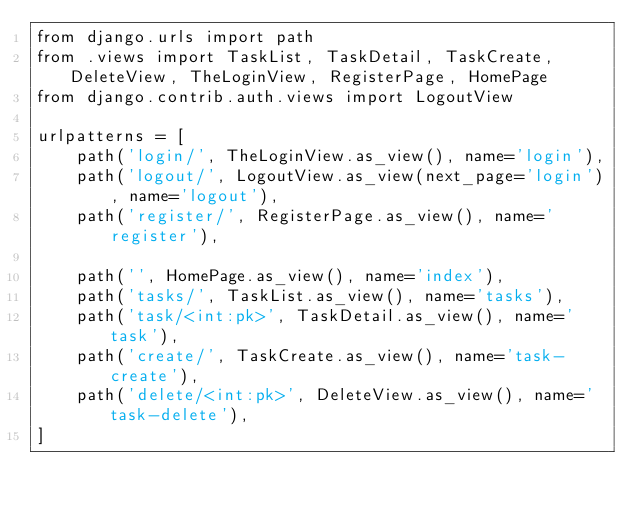<code> <loc_0><loc_0><loc_500><loc_500><_Python_>from django.urls import path
from .views import TaskList, TaskDetail, TaskCreate, DeleteView, TheLoginView, RegisterPage, HomePage
from django.contrib.auth.views import LogoutView

urlpatterns = [
    path('login/', TheLoginView.as_view(), name='login'),
    path('logout/', LogoutView.as_view(next_page='login'), name='logout'),
    path('register/', RegisterPage.as_view(), name='register'),

    path('', HomePage.as_view(), name='index'),
    path('tasks/', TaskList.as_view(), name='tasks'),
    path('task/<int:pk>', TaskDetail.as_view(), name='task'),
    path('create/', TaskCreate.as_view(), name='task-create'),
    path('delete/<int:pk>', DeleteView.as_view(), name='task-delete'),
]</code> 